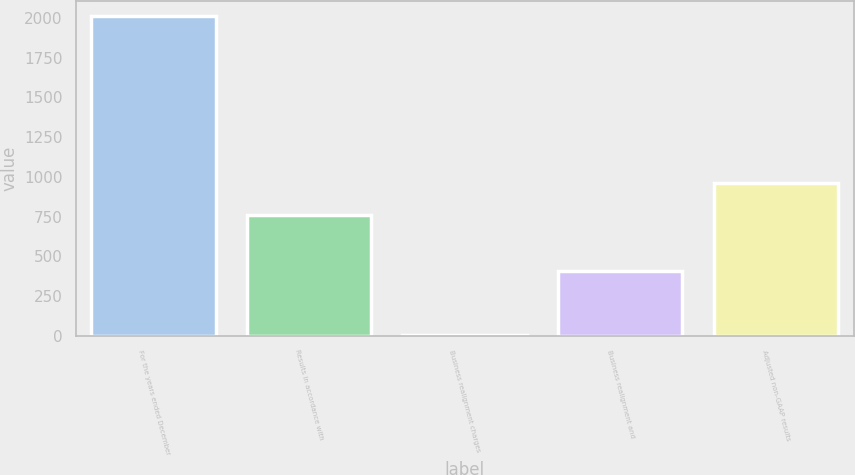Convert chart. <chart><loc_0><loc_0><loc_500><loc_500><bar_chart><fcel>For the years ended December<fcel>Results in accordance with<fcel>Business realignment charges<fcel>Business realignment and<fcel>Adjusted non-GAAP results<nl><fcel>2009<fcel>761.6<fcel>6.1<fcel>406.68<fcel>961.89<nl></chart> 